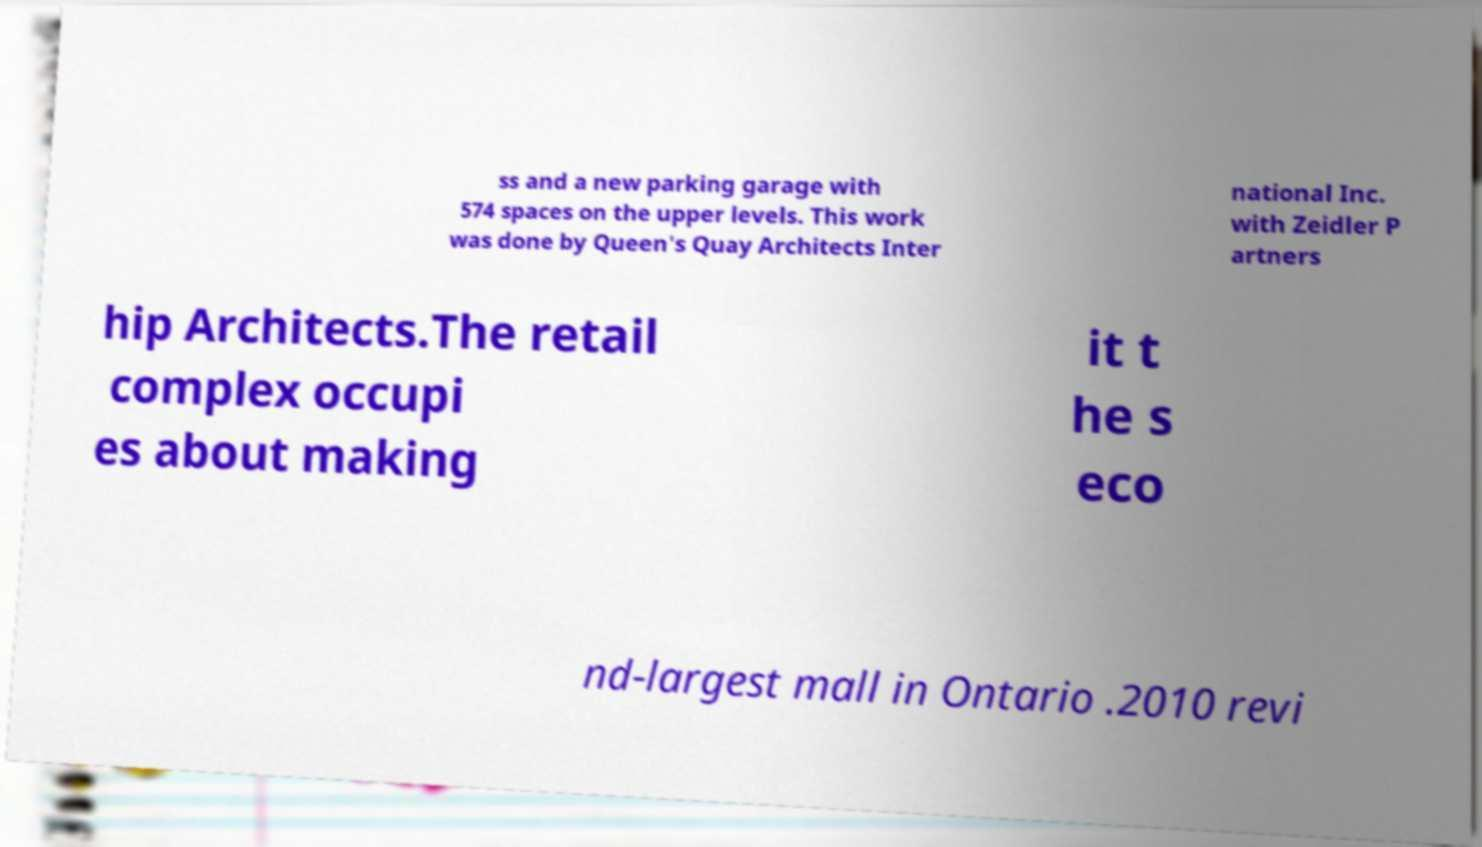Please identify and transcribe the text found in this image. ss and a new parking garage with 574 spaces on the upper levels. This work was done by Queen's Quay Architects Inter national Inc. with Zeidler P artners hip Architects.The retail complex occupi es about making it t he s eco nd-largest mall in Ontario .2010 revi 